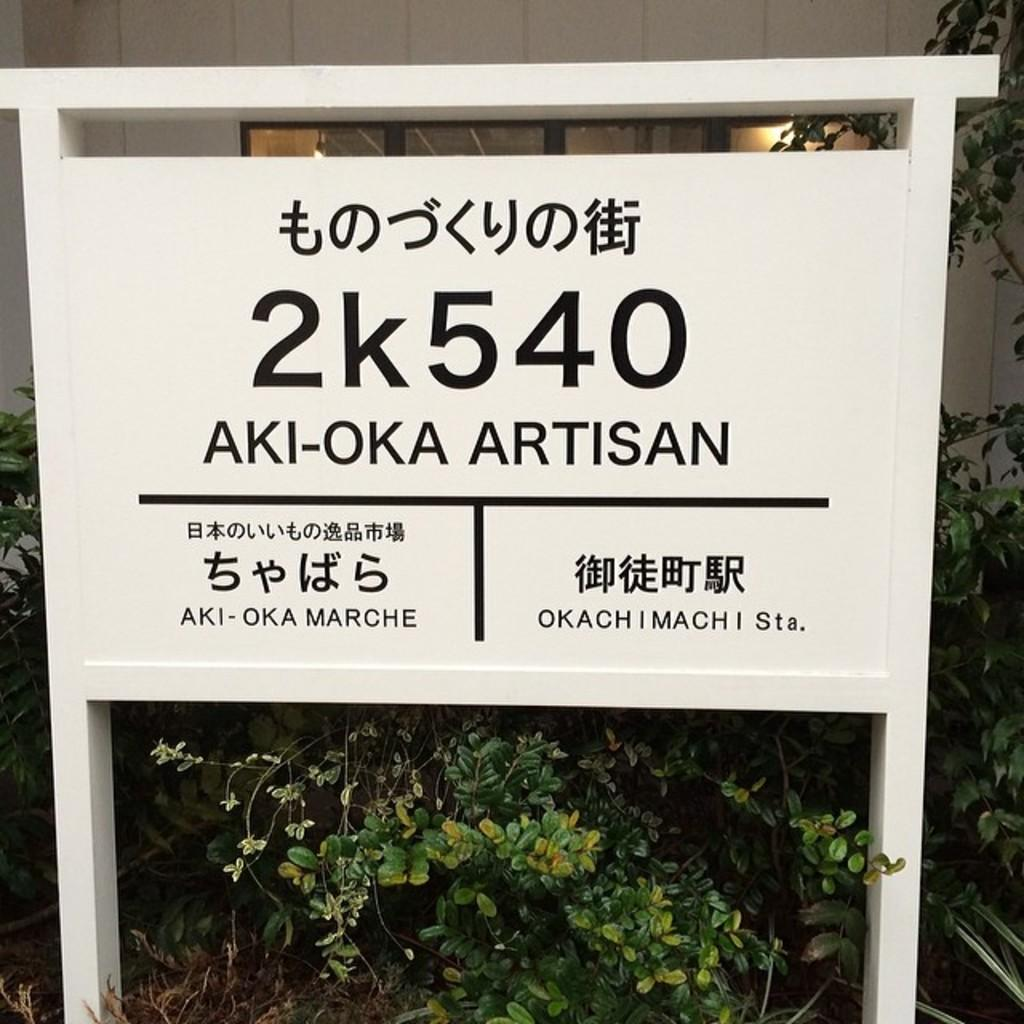What is present on the board in the image? There is written text on a board in the image. What type of natural environment can be seen in the image? There are trees visible in the image. What is located in the background of the image? There is a wall and a glass window in the background of the image. What type of plate is being used to serve the word in the image? There is no plate or word present in the image. 